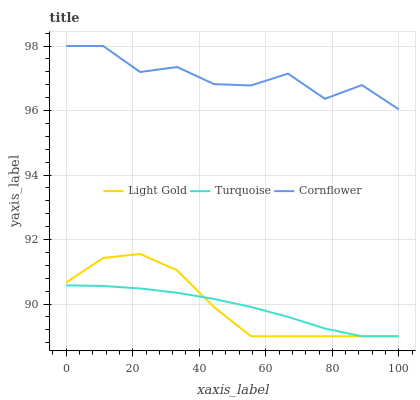Does Turquoise have the minimum area under the curve?
Answer yes or no. Yes. Does Cornflower have the maximum area under the curve?
Answer yes or no. Yes. Does Light Gold have the minimum area under the curve?
Answer yes or no. No. Does Light Gold have the maximum area under the curve?
Answer yes or no. No. Is Turquoise the smoothest?
Answer yes or no. Yes. Is Cornflower the roughest?
Answer yes or no. Yes. Is Light Gold the smoothest?
Answer yes or no. No. Is Light Gold the roughest?
Answer yes or no. No. Does Turquoise have the lowest value?
Answer yes or no. Yes. Does Cornflower have the highest value?
Answer yes or no. Yes. Does Light Gold have the highest value?
Answer yes or no. No. Is Light Gold less than Cornflower?
Answer yes or no. Yes. Is Cornflower greater than Turquoise?
Answer yes or no. Yes. Does Turquoise intersect Light Gold?
Answer yes or no. Yes. Is Turquoise less than Light Gold?
Answer yes or no. No. Is Turquoise greater than Light Gold?
Answer yes or no. No. Does Light Gold intersect Cornflower?
Answer yes or no. No. 